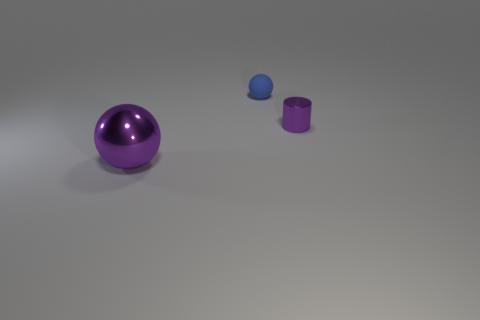There is a blue ball; are there any purple metal objects in front of it? Yes, there is a purple metal cylinder positioned in front of the blue ball when viewed from the perspective of the image. 